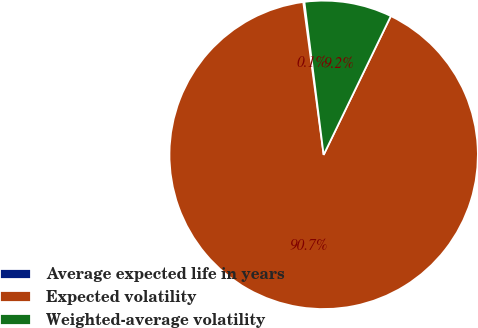<chart> <loc_0><loc_0><loc_500><loc_500><pie_chart><fcel>Average expected life in years<fcel>Expected volatility<fcel>Weighted-average volatility<nl><fcel>0.12%<fcel>90.71%<fcel>9.17%<nl></chart> 